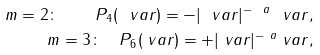<formula> <loc_0><loc_0><loc_500><loc_500>m = 2 \colon \quad P _ { 4 } ( \ v a r ) = - | \ v a r | ^ { - \ a } \ v a r , \\ m = 3 \colon \quad P _ { 6 } ( \ v a r ) = + | \ v a r | ^ { - \ a } \ v a r ,</formula> 